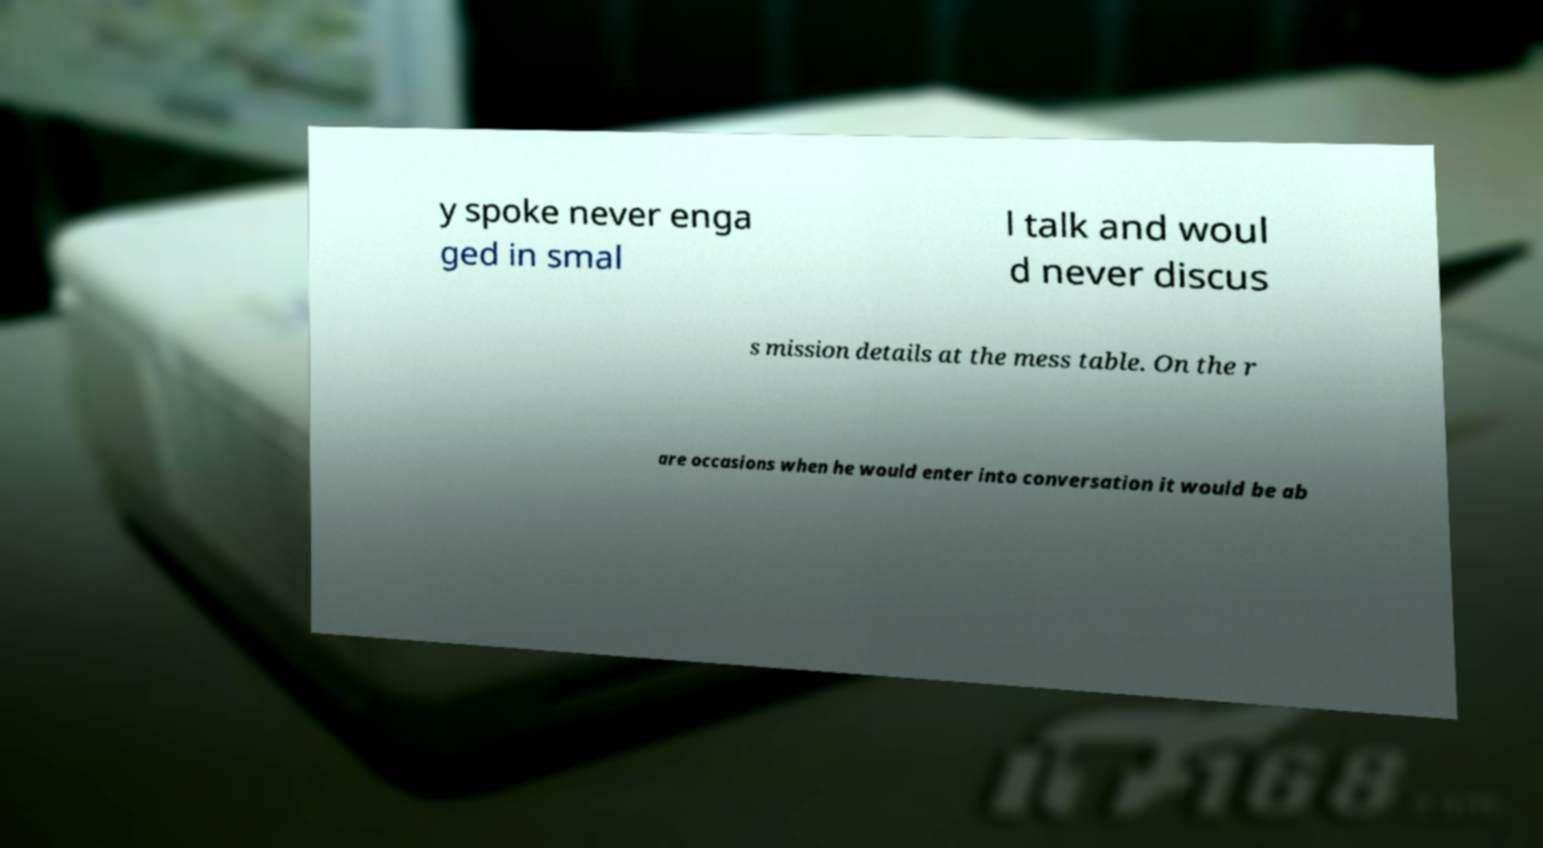Please read and relay the text visible in this image. What does it say? y spoke never enga ged in smal l talk and woul d never discus s mission details at the mess table. On the r are occasions when he would enter into conversation it would be ab 